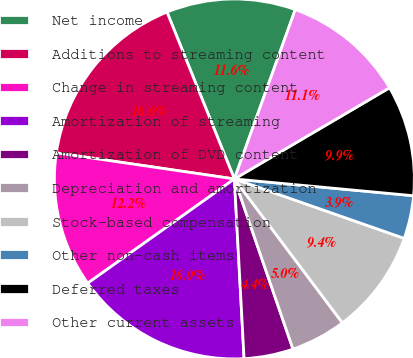Convert chart to OTSL. <chart><loc_0><loc_0><loc_500><loc_500><pie_chart><fcel>Net income<fcel>Additions to streaming content<fcel>Change in streaming content<fcel>Amortization of streaming<fcel>Amortization of DVD content<fcel>Depreciation and amortization<fcel>Stock-based compensation<fcel>Other non-cash items<fcel>Deferred taxes<fcel>Other current assets<nl><fcel>11.6%<fcel>16.57%<fcel>12.15%<fcel>16.02%<fcel>4.42%<fcel>4.97%<fcel>9.39%<fcel>3.87%<fcel>9.94%<fcel>11.05%<nl></chart> 